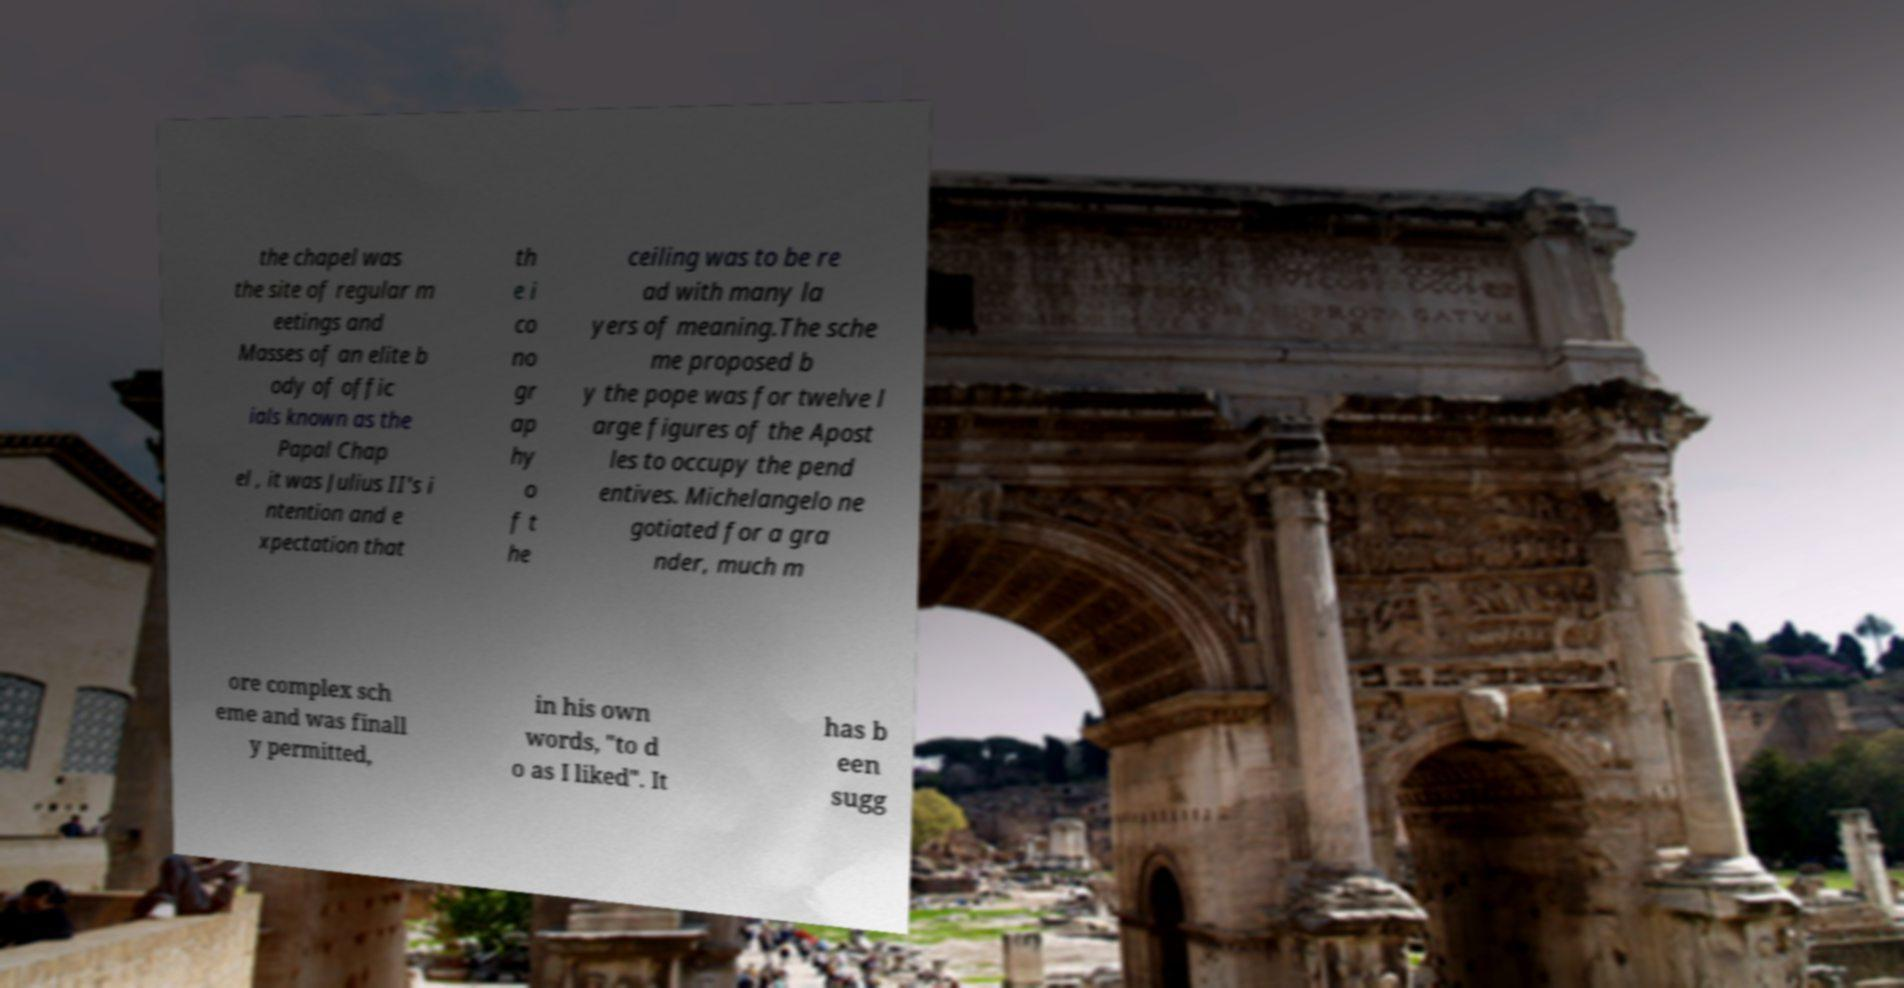Could you assist in decoding the text presented in this image and type it out clearly? the chapel was the site of regular m eetings and Masses of an elite b ody of offic ials known as the Papal Chap el , it was Julius II's i ntention and e xpectation that th e i co no gr ap hy o f t he ceiling was to be re ad with many la yers of meaning.The sche me proposed b y the pope was for twelve l arge figures of the Apost les to occupy the pend entives. Michelangelo ne gotiated for a gra nder, much m ore complex sch eme and was finall y permitted, in his own words, "to d o as I liked". It has b een sugg 